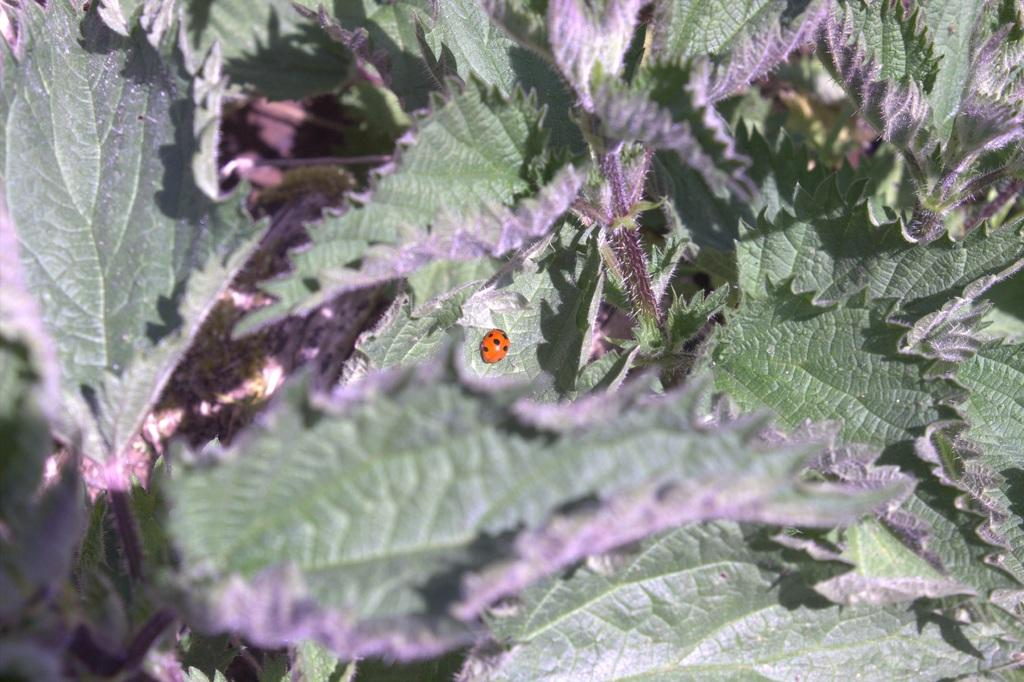What type of vegetation can be seen in the image? There are green leaves in the image. Can you describe any living organisms present on the green leaves? Yes, there is an insect on one of the green leaves. What type of story is being told in the church in the image? There is no church or story present in the image; it features green leaves with an insect on one of them. 